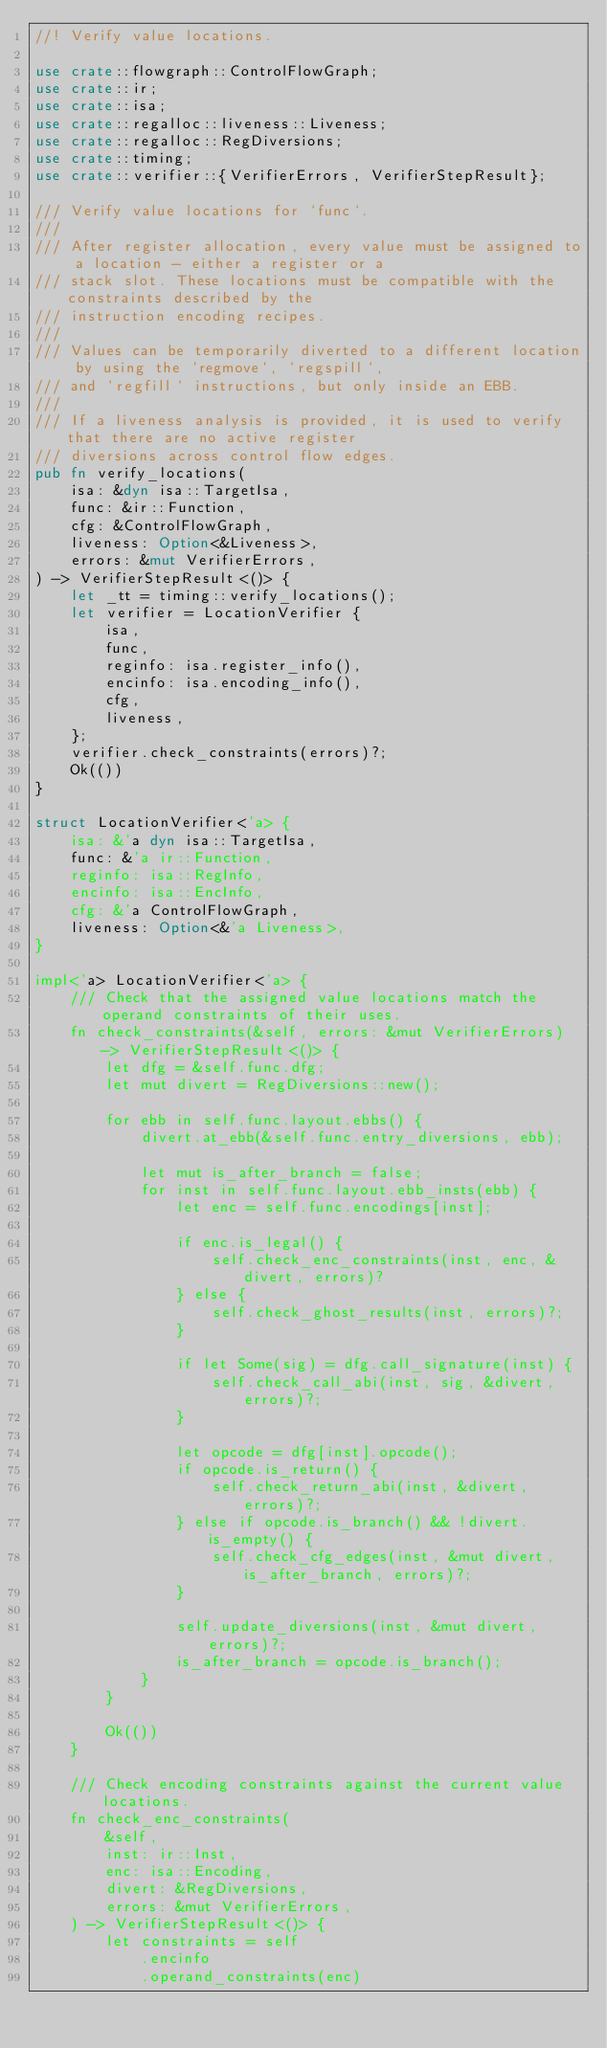Convert code to text. <code><loc_0><loc_0><loc_500><loc_500><_Rust_>//! Verify value locations.

use crate::flowgraph::ControlFlowGraph;
use crate::ir;
use crate::isa;
use crate::regalloc::liveness::Liveness;
use crate::regalloc::RegDiversions;
use crate::timing;
use crate::verifier::{VerifierErrors, VerifierStepResult};

/// Verify value locations for `func`.
///
/// After register allocation, every value must be assigned to a location - either a register or a
/// stack slot. These locations must be compatible with the constraints described by the
/// instruction encoding recipes.
///
/// Values can be temporarily diverted to a different location by using the `regmove`, `regspill`,
/// and `regfill` instructions, but only inside an EBB.
///
/// If a liveness analysis is provided, it is used to verify that there are no active register
/// diversions across control flow edges.
pub fn verify_locations(
    isa: &dyn isa::TargetIsa,
    func: &ir::Function,
    cfg: &ControlFlowGraph,
    liveness: Option<&Liveness>,
    errors: &mut VerifierErrors,
) -> VerifierStepResult<()> {
    let _tt = timing::verify_locations();
    let verifier = LocationVerifier {
        isa,
        func,
        reginfo: isa.register_info(),
        encinfo: isa.encoding_info(),
        cfg,
        liveness,
    };
    verifier.check_constraints(errors)?;
    Ok(())
}

struct LocationVerifier<'a> {
    isa: &'a dyn isa::TargetIsa,
    func: &'a ir::Function,
    reginfo: isa::RegInfo,
    encinfo: isa::EncInfo,
    cfg: &'a ControlFlowGraph,
    liveness: Option<&'a Liveness>,
}

impl<'a> LocationVerifier<'a> {
    /// Check that the assigned value locations match the operand constraints of their uses.
    fn check_constraints(&self, errors: &mut VerifierErrors) -> VerifierStepResult<()> {
        let dfg = &self.func.dfg;
        let mut divert = RegDiversions::new();

        for ebb in self.func.layout.ebbs() {
            divert.at_ebb(&self.func.entry_diversions, ebb);

            let mut is_after_branch = false;
            for inst in self.func.layout.ebb_insts(ebb) {
                let enc = self.func.encodings[inst];

                if enc.is_legal() {
                    self.check_enc_constraints(inst, enc, &divert, errors)?
                } else {
                    self.check_ghost_results(inst, errors)?;
                }

                if let Some(sig) = dfg.call_signature(inst) {
                    self.check_call_abi(inst, sig, &divert, errors)?;
                }

                let opcode = dfg[inst].opcode();
                if opcode.is_return() {
                    self.check_return_abi(inst, &divert, errors)?;
                } else if opcode.is_branch() && !divert.is_empty() {
                    self.check_cfg_edges(inst, &mut divert, is_after_branch, errors)?;
                }

                self.update_diversions(inst, &mut divert, errors)?;
                is_after_branch = opcode.is_branch();
            }
        }

        Ok(())
    }

    /// Check encoding constraints against the current value locations.
    fn check_enc_constraints(
        &self,
        inst: ir::Inst,
        enc: isa::Encoding,
        divert: &RegDiversions,
        errors: &mut VerifierErrors,
    ) -> VerifierStepResult<()> {
        let constraints = self
            .encinfo
            .operand_constraints(enc)</code> 